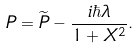Convert formula to latex. <formula><loc_0><loc_0><loc_500><loc_500>P = \widetilde { P } - \frac { i \hbar { \lambda } } { 1 + X ^ { 2 } } .</formula> 